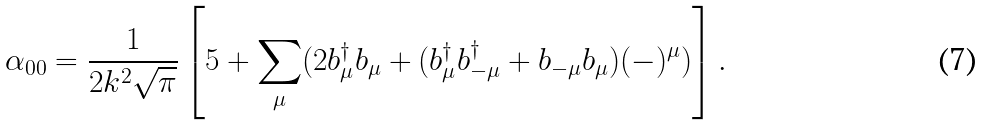<formula> <loc_0><loc_0><loc_500><loc_500>\alpha _ { 0 0 } = \frac { 1 } { 2 k ^ { 2 } \sqrt { \pi } } \left [ 5 + \sum _ { \mu } ( 2 b ^ { \dagger } _ { \mu } b _ { \mu } + ( b ^ { \dagger } _ { \mu } b ^ { \dagger } _ { - \mu } + b _ { - \mu } b _ { \mu } ) ( - ) ^ { \mu } ) \right ] .</formula> 